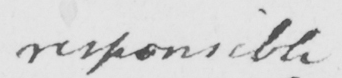Can you tell me what this handwritten text says? responsible 